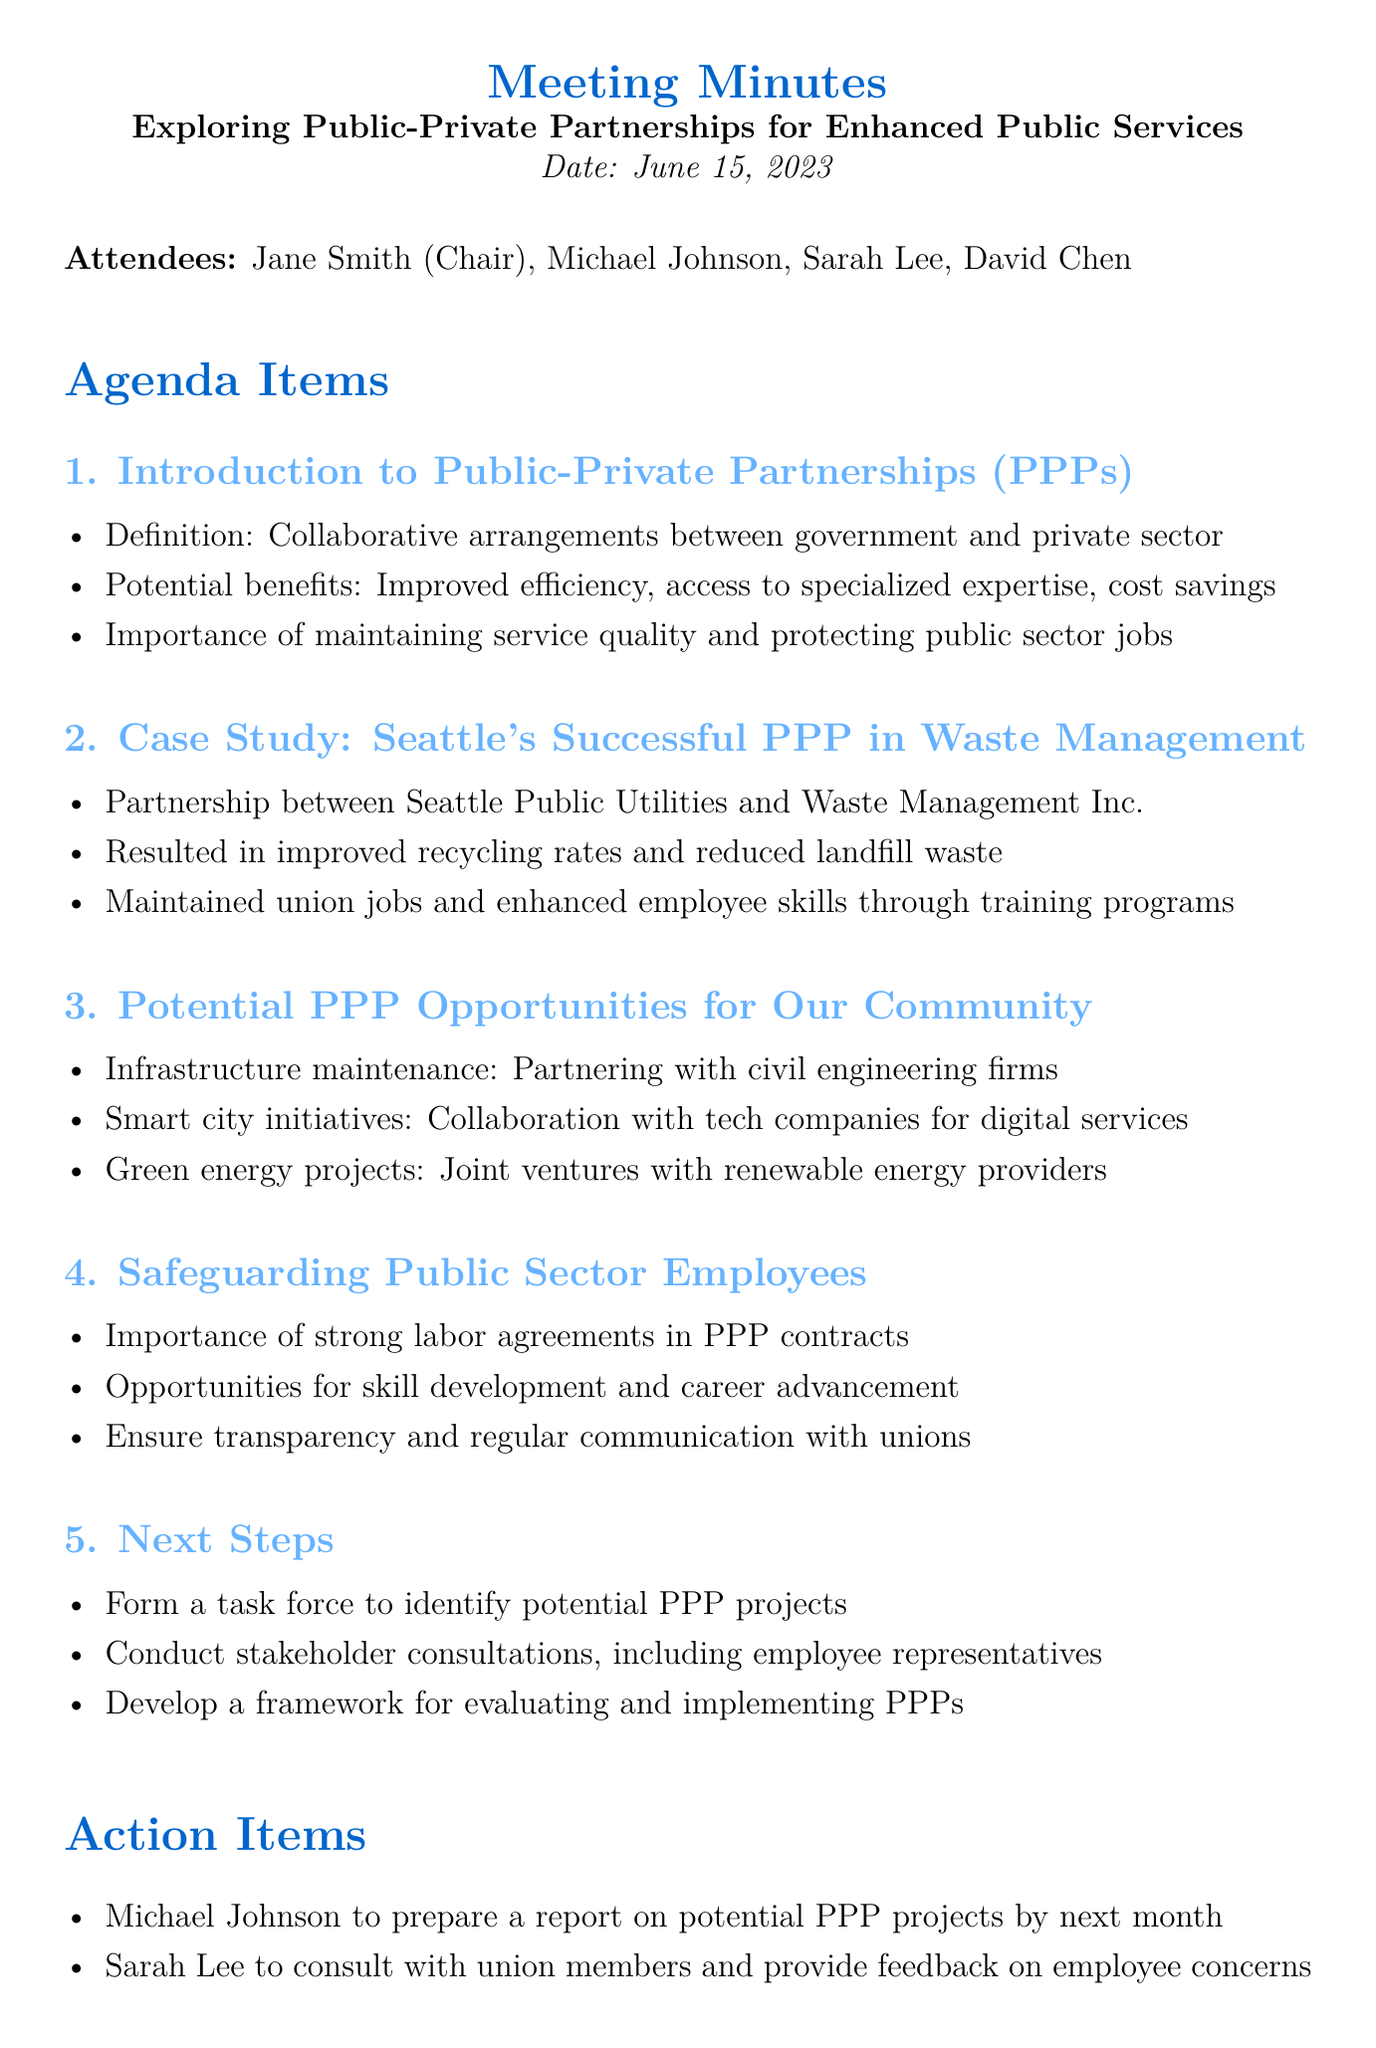What is the date of the meeting? The date of the meeting is explicitly mentioned in the document.
Answer: June 15, 2023 Who chaired the meeting? The document specifies the chair of the meeting among the attendees.
Answer: Jane Smith What was the title of the case study discussed? The case study title is highlighted in the agenda items section.
Answer: Seattle's Successful PPP in Waste Management What is one potential PPP opportunity for the community? The document lists three potential PPP opportunities under the corresponding agenda item.
Answer: Infrastructure maintenance What is one action item assigned to Michael Johnson? The document provides a specific action item linked to Michael Johnson.
Answer: Prepare a report on potential PPP projects by next month How many attendees were listed in the meeting minutes? The document notes the number of individuals present at the meeting.
Answer: Four What is emphasized as important in safeguarding public sector employees? The document outlines key points in the agenda item about safeguarding employees.
Answer: Strong labor agreements What is the purpose of forming a task force? This is explained directly in the next steps section of the document.
Answer: Identify potential PPP projects 